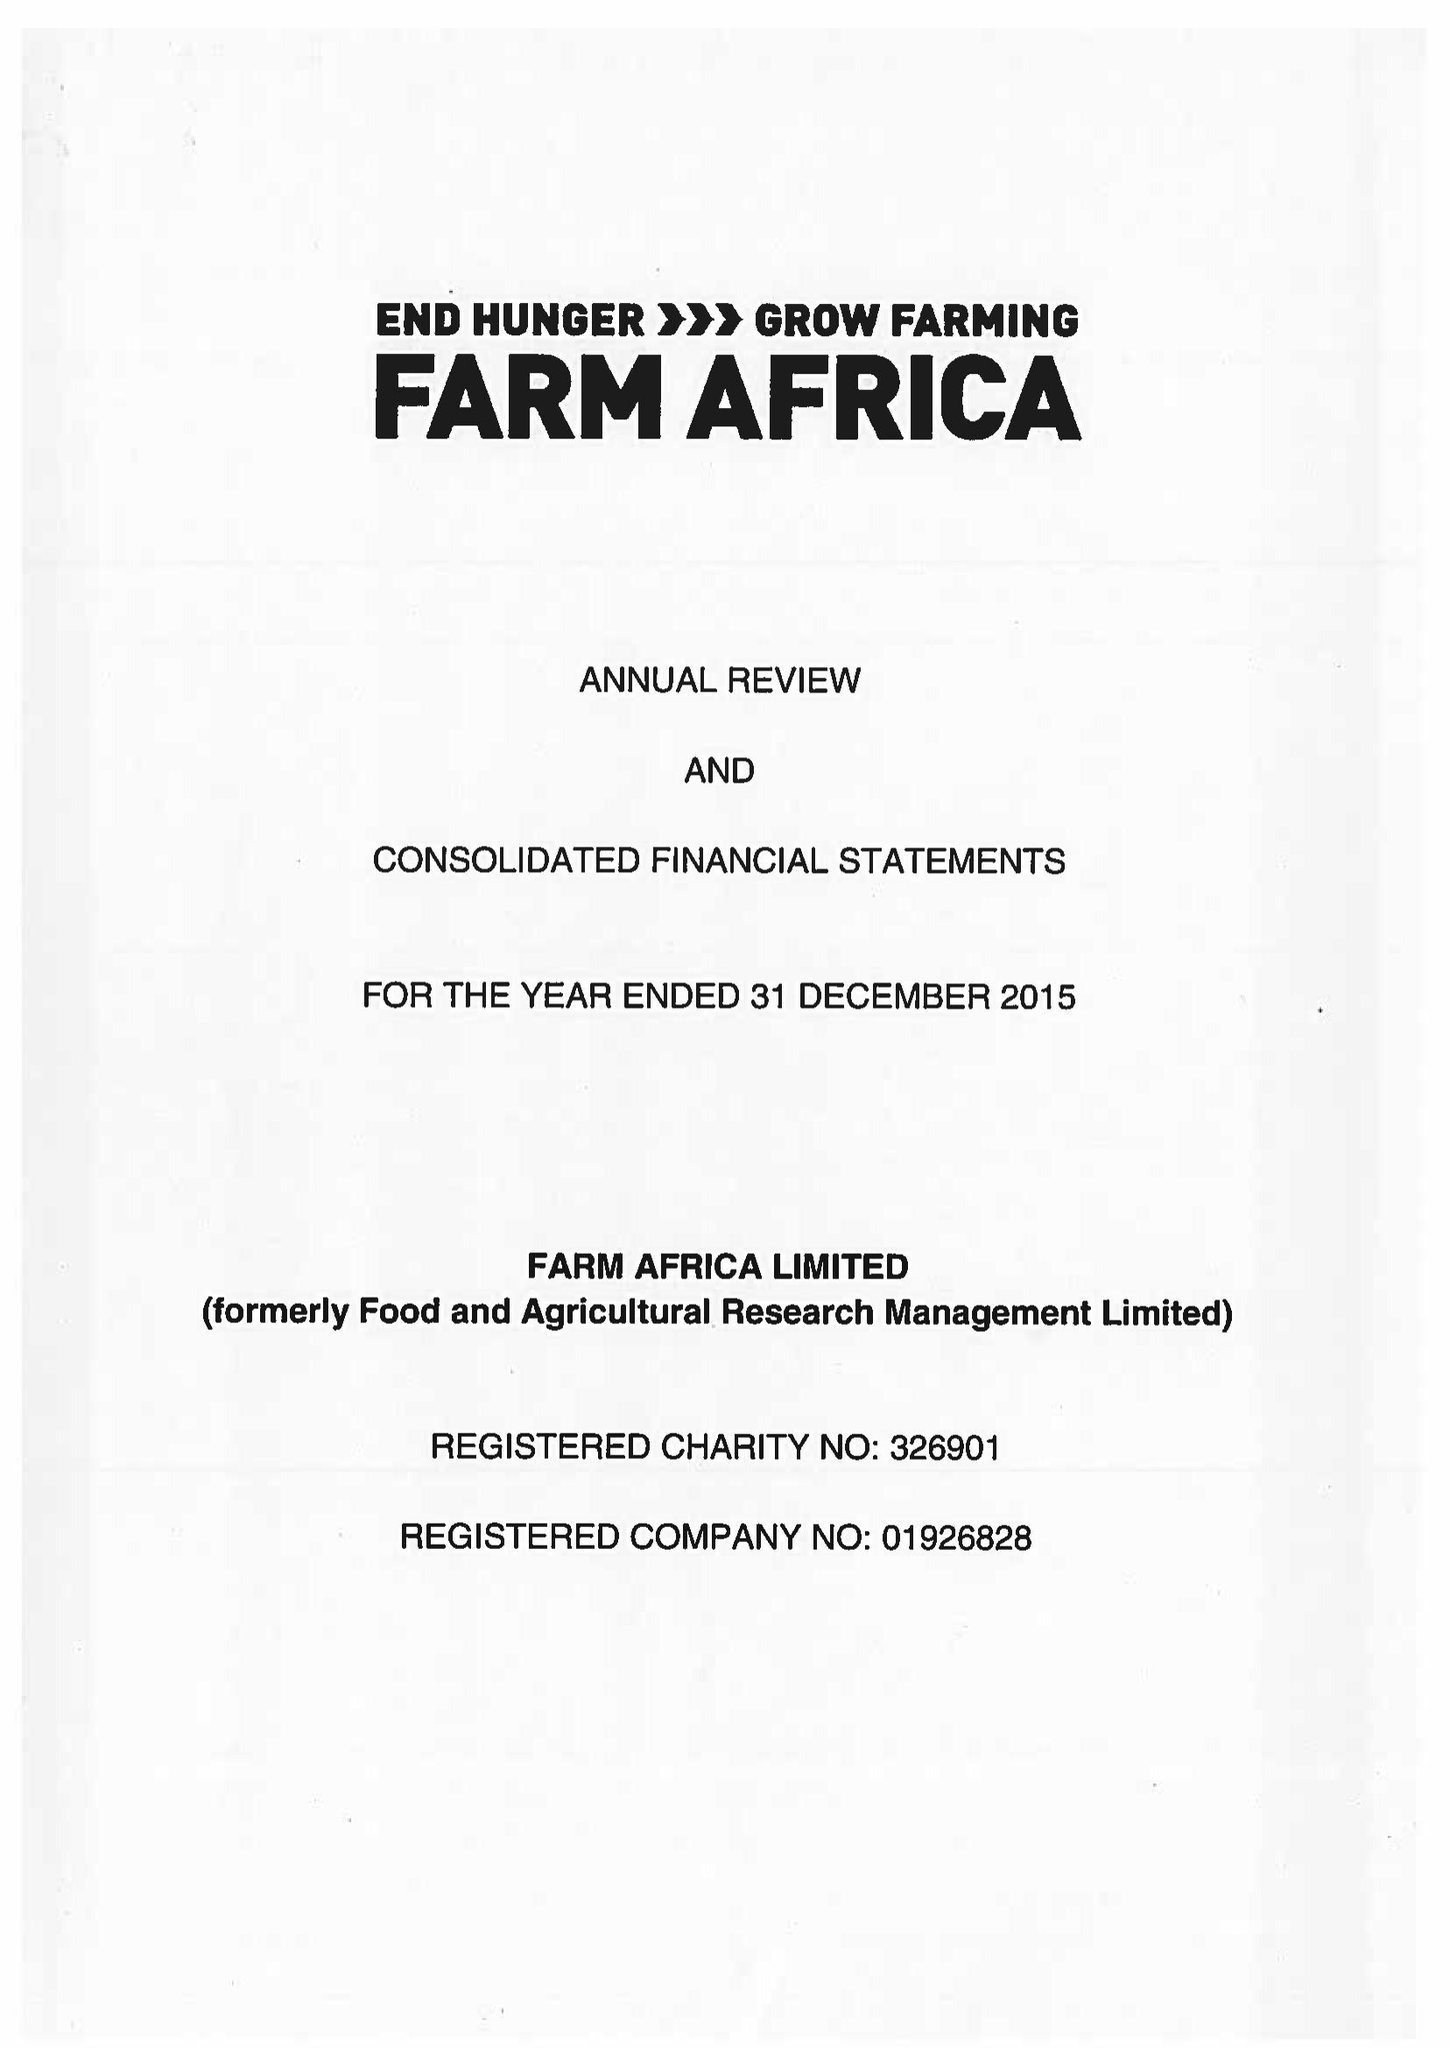What is the value for the address__post_town?
Answer the question using a single word or phrase. LONDON 